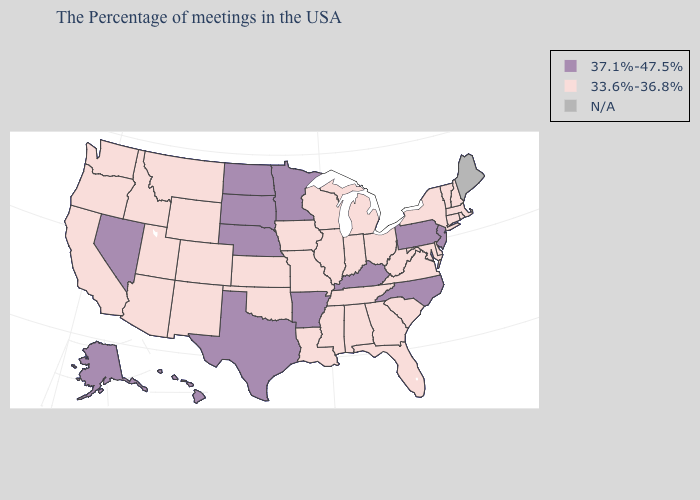Does Nevada have the highest value in the USA?
Be succinct. Yes. What is the lowest value in the USA?
Keep it brief. 33.6%-36.8%. Which states have the lowest value in the USA?
Answer briefly. Massachusetts, Rhode Island, New Hampshire, Vermont, Connecticut, New York, Delaware, Maryland, Virginia, South Carolina, West Virginia, Ohio, Florida, Georgia, Michigan, Indiana, Alabama, Tennessee, Wisconsin, Illinois, Mississippi, Louisiana, Missouri, Iowa, Kansas, Oklahoma, Wyoming, Colorado, New Mexico, Utah, Montana, Arizona, Idaho, California, Washington, Oregon. What is the value of Texas?
Answer briefly. 37.1%-47.5%. Name the states that have a value in the range N/A?
Keep it brief. Maine. What is the value of South Dakota?
Answer briefly. 37.1%-47.5%. Does Arkansas have the highest value in the USA?
Give a very brief answer. Yes. Does Hawaii have the lowest value in the USA?
Write a very short answer. No. What is the value of Montana?
Quick response, please. 33.6%-36.8%. Among the states that border Nebraska , does Colorado have the highest value?
Give a very brief answer. No. Name the states that have a value in the range 37.1%-47.5%?
Concise answer only. New Jersey, Pennsylvania, North Carolina, Kentucky, Arkansas, Minnesota, Nebraska, Texas, South Dakota, North Dakota, Nevada, Alaska, Hawaii. Name the states that have a value in the range N/A?
Give a very brief answer. Maine. 